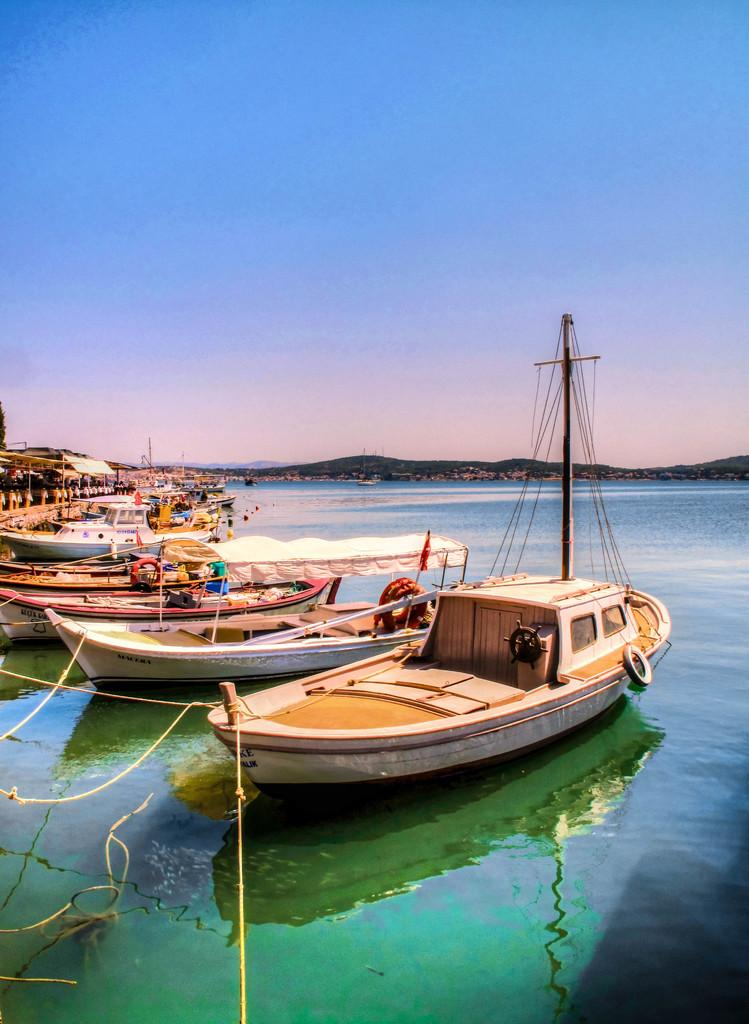What type of vehicles are in the image? There are boats in the image. What color are the boats? The boats are white in color. Where are the boats located? The boats are in water. What can be seen in the background of the image? There are mountains visible in the background of the image. How would you describe the sky in the image? The sky is white and blue in color. What type of quilt is being used to cover the boats in the image? There is no quilt present in the image; the boats are in water. Can you see any blades attached to the boats in the image? There is no mention of blades in the image; the boats are simply white in color. 